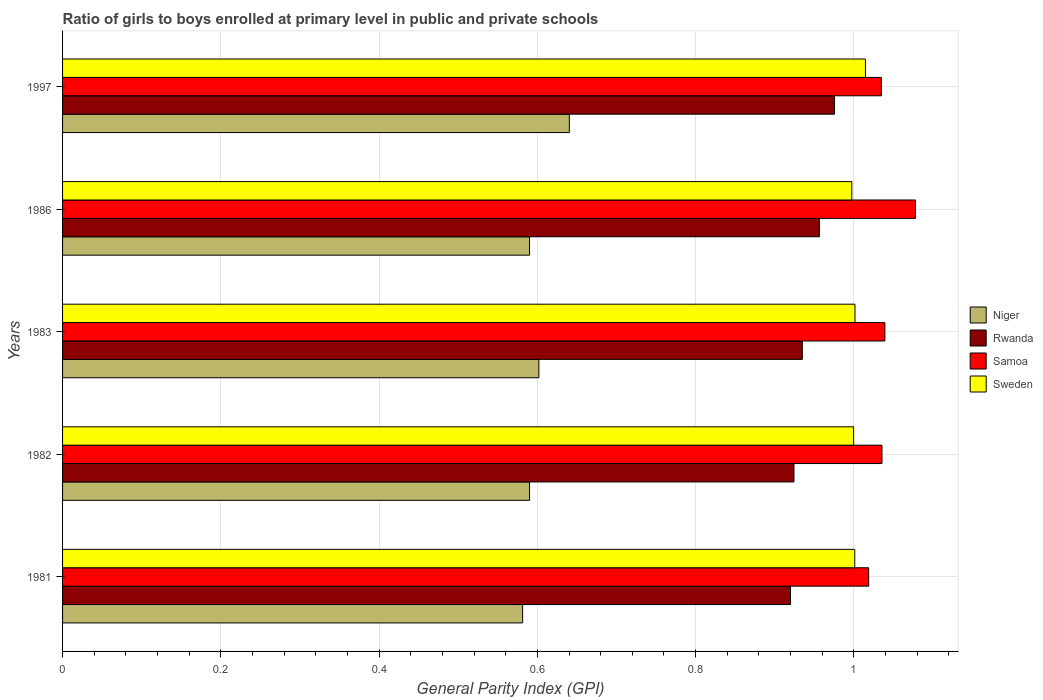Are the number of bars per tick equal to the number of legend labels?
Make the answer very short. Yes. Are the number of bars on each tick of the Y-axis equal?
Your response must be concise. Yes. How many bars are there on the 4th tick from the top?
Your answer should be very brief. 4. How many bars are there on the 5th tick from the bottom?
Ensure brevity in your answer.  4. In how many cases, is the number of bars for a given year not equal to the number of legend labels?
Offer a very short reply. 0. What is the general parity index in Sweden in 1986?
Keep it short and to the point. 1. Across all years, what is the maximum general parity index in Rwanda?
Provide a short and direct response. 0.98. Across all years, what is the minimum general parity index in Samoa?
Provide a short and direct response. 1.02. What is the total general parity index in Sweden in the graph?
Offer a very short reply. 5.01. What is the difference between the general parity index in Samoa in 1981 and that in 1982?
Your answer should be very brief. -0.02. What is the difference between the general parity index in Rwanda in 1997 and the general parity index in Niger in 1982?
Provide a succinct answer. 0.39. What is the average general parity index in Sweden per year?
Offer a terse response. 1. In the year 1986, what is the difference between the general parity index in Samoa and general parity index in Rwanda?
Keep it short and to the point. 0.12. In how many years, is the general parity index in Rwanda greater than 0.2 ?
Offer a terse response. 5. What is the ratio of the general parity index in Niger in 1983 to that in 1997?
Your response must be concise. 0.94. Is the general parity index in Niger in 1982 less than that in 1997?
Keep it short and to the point. Yes. Is the difference between the general parity index in Samoa in 1981 and 1997 greater than the difference between the general parity index in Rwanda in 1981 and 1997?
Offer a terse response. Yes. What is the difference between the highest and the second highest general parity index in Sweden?
Keep it short and to the point. 0.01. What is the difference between the highest and the lowest general parity index in Samoa?
Provide a short and direct response. 0.06. What does the 2nd bar from the top in 1986 represents?
Ensure brevity in your answer.  Samoa. What does the 4th bar from the bottom in 1982 represents?
Your answer should be compact. Sweden. How many bars are there?
Offer a very short reply. 20. Are the values on the major ticks of X-axis written in scientific E-notation?
Make the answer very short. No. Does the graph contain grids?
Provide a short and direct response. Yes. Where does the legend appear in the graph?
Your answer should be compact. Center right. How many legend labels are there?
Your response must be concise. 4. What is the title of the graph?
Ensure brevity in your answer.  Ratio of girls to boys enrolled at primary level in public and private schools. Does "Turkmenistan" appear as one of the legend labels in the graph?
Give a very brief answer. No. What is the label or title of the X-axis?
Keep it short and to the point. General Parity Index (GPI). What is the label or title of the Y-axis?
Offer a very short reply. Years. What is the General Parity Index (GPI) in Niger in 1981?
Keep it short and to the point. 0.58. What is the General Parity Index (GPI) of Rwanda in 1981?
Your response must be concise. 0.92. What is the General Parity Index (GPI) of Samoa in 1981?
Your response must be concise. 1.02. What is the General Parity Index (GPI) in Sweden in 1981?
Provide a succinct answer. 1. What is the General Parity Index (GPI) in Niger in 1982?
Offer a terse response. 0.59. What is the General Parity Index (GPI) in Rwanda in 1982?
Ensure brevity in your answer.  0.92. What is the General Parity Index (GPI) of Samoa in 1982?
Offer a very short reply. 1.04. What is the General Parity Index (GPI) in Sweden in 1982?
Offer a very short reply. 1. What is the General Parity Index (GPI) in Niger in 1983?
Your answer should be compact. 0.6. What is the General Parity Index (GPI) in Rwanda in 1983?
Ensure brevity in your answer.  0.93. What is the General Parity Index (GPI) of Samoa in 1983?
Ensure brevity in your answer.  1.04. What is the General Parity Index (GPI) of Sweden in 1983?
Keep it short and to the point. 1. What is the General Parity Index (GPI) in Niger in 1986?
Ensure brevity in your answer.  0.59. What is the General Parity Index (GPI) of Rwanda in 1986?
Your answer should be compact. 0.96. What is the General Parity Index (GPI) of Samoa in 1986?
Make the answer very short. 1.08. What is the General Parity Index (GPI) in Sweden in 1986?
Offer a terse response. 1. What is the General Parity Index (GPI) of Niger in 1997?
Ensure brevity in your answer.  0.64. What is the General Parity Index (GPI) of Rwanda in 1997?
Make the answer very short. 0.98. What is the General Parity Index (GPI) of Samoa in 1997?
Provide a succinct answer. 1.03. What is the General Parity Index (GPI) in Sweden in 1997?
Keep it short and to the point. 1.01. Across all years, what is the maximum General Parity Index (GPI) of Niger?
Your answer should be compact. 0.64. Across all years, what is the maximum General Parity Index (GPI) in Rwanda?
Your response must be concise. 0.98. Across all years, what is the maximum General Parity Index (GPI) in Samoa?
Provide a short and direct response. 1.08. Across all years, what is the maximum General Parity Index (GPI) in Sweden?
Ensure brevity in your answer.  1.01. Across all years, what is the minimum General Parity Index (GPI) in Niger?
Offer a very short reply. 0.58. Across all years, what is the minimum General Parity Index (GPI) of Rwanda?
Provide a short and direct response. 0.92. Across all years, what is the minimum General Parity Index (GPI) in Samoa?
Offer a terse response. 1.02. Across all years, what is the minimum General Parity Index (GPI) in Sweden?
Offer a very short reply. 1. What is the total General Parity Index (GPI) of Niger in the graph?
Give a very brief answer. 3. What is the total General Parity Index (GPI) in Rwanda in the graph?
Offer a very short reply. 4.71. What is the total General Parity Index (GPI) of Samoa in the graph?
Offer a very short reply. 5.21. What is the total General Parity Index (GPI) in Sweden in the graph?
Make the answer very short. 5.01. What is the difference between the General Parity Index (GPI) of Niger in 1981 and that in 1982?
Provide a short and direct response. -0.01. What is the difference between the General Parity Index (GPI) in Rwanda in 1981 and that in 1982?
Offer a terse response. -0. What is the difference between the General Parity Index (GPI) of Samoa in 1981 and that in 1982?
Your answer should be very brief. -0.02. What is the difference between the General Parity Index (GPI) in Sweden in 1981 and that in 1982?
Offer a very short reply. 0. What is the difference between the General Parity Index (GPI) in Niger in 1981 and that in 1983?
Give a very brief answer. -0.02. What is the difference between the General Parity Index (GPI) in Rwanda in 1981 and that in 1983?
Make the answer very short. -0.01. What is the difference between the General Parity Index (GPI) in Samoa in 1981 and that in 1983?
Make the answer very short. -0.02. What is the difference between the General Parity Index (GPI) of Sweden in 1981 and that in 1983?
Your answer should be very brief. -0. What is the difference between the General Parity Index (GPI) of Niger in 1981 and that in 1986?
Your response must be concise. -0.01. What is the difference between the General Parity Index (GPI) of Rwanda in 1981 and that in 1986?
Your response must be concise. -0.04. What is the difference between the General Parity Index (GPI) in Samoa in 1981 and that in 1986?
Give a very brief answer. -0.06. What is the difference between the General Parity Index (GPI) of Sweden in 1981 and that in 1986?
Your response must be concise. 0. What is the difference between the General Parity Index (GPI) of Niger in 1981 and that in 1997?
Give a very brief answer. -0.06. What is the difference between the General Parity Index (GPI) in Rwanda in 1981 and that in 1997?
Provide a succinct answer. -0.06. What is the difference between the General Parity Index (GPI) of Samoa in 1981 and that in 1997?
Your answer should be compact. -0.02. What is the difference between the General Parity Index (GPI) of Sweden in 1981 and that in 1997?
Provide a succinct answer. -0.01. What is the difference between the General Parity Index (GPI) of Niger in 1982 and that in 1983?
Your answer should be very brief. -0.01. What is the difference between the General Parity Index (GPI) in Rwanda in 1982 and that in 1983?
Give a very brief answer. -0.01. What is the difference between the General Parity Index (GPI) in Samoa in 1982 and that in 1983?
Your response must be concise. -0. What is the difference between the General Parity Index (GPI) of Sweden in 1982 and that in 1983?
Give a very brief answer. -0. What is the difference between the General Parity Index (GPI) in Rwanda in 1982 and that in 1986?
Offer a terse response. -0.03. What is the difference between the General Parity Index (GPI) in Samoa in 1982 and that in 1986?
Offer a terse response. -0.04. What is the difference between the General Parity Index (GPI) of Sweden in 1982 and that in 1986?
Your answer should be very brief. 0. What is the difference between the General Parity Index (GPI) in Niger in 1982 and that in 1997?
Offer a terse response. -0.05. What is the difference between the General Parity Index (GPI) in Rwanda in 1982 and that in 1997?
Offer a very short reply. -0.05. What is the difference between the General Parity Index (GPI) of Samoa in 1982 and that in 1997?
Offer a terse response. 0. What is the difference between the General Parity Index (GPI) of Sweden in 1982 and that in 1997?
Make the answer very short. -0.01. What is the difference between the General Parity Index (GPI) of Niger in 1983 and that in 1986?
Make the answer very short. 0.01. What is the difference between the General Parity Index (GPI) in Rwanda in 1983 and that in 1986?
Provide a succinct answer. -0.02. What is the difference between the General Parity Index (GPI) in Samoa in 1983 and that in 1986?
Give a very brief answer. -0.04. What is the difference between the General Parity Index (GPI) in Sweden in 1983 and that in 1986?
Provide a succinct answer. 0. What is the difference between the General Parity Index (GPI) of Niger in 1983 and that in 1997?
Ensure brevity in your answer.  -0.04. What is the difference between the General Parity Index (GPI) in Rwanda in 1983 and that in 1997?
Provide a succinct answer. -0.04. What is the difference between the General Parity Index (GPI) in Samoa in 1983 and that in 1997?
Provide a succinct answer. 0. What is the difference between the General Parity Index (GPI) of Sweden in 1983 and that in 1997?
Offer a very short reply. -0.01. What is the difference between the General Parity Index (GPI) in Niger in 1986 and that in 1997?
Give a very brief answer. -0.05. What is the difference between the General Parity Index (GPI) of Rwanda in 1986 and that in 1997?
Provide a short and direct response. -0.02. What is the difference between the General Parity Index (GPI) in Samoa in 1986 and that in 1997?
Offer a terse response. 0.04. What is the difference between the General Parity Index (GPI) in Sweden in 1986 and that in 1997?
Your answer should be very brief. -0.02. What is the difference between the General Parity Index (GPI) in Niger in 1981 and the General Parity Index (GPI) in Rwanda in 1982?
Offer a very short reply. -0.34. What is the difference between the General Parity Index (GPI) in Niger in 1981 and the General Parity Index (GPI) in Samoa in 1982?
Keep it short and to the point. -0.45. What is the difference between the General Parity Index (GPI) in Niger in 1981 and the General Parity Index (GPI) in Sweden in 1982?
Make the answer very short. -0.42. What is the difference between the General Parity Index (GPI) of Rwanda in 1981 and the General Parity Index (GPI) of Samoa in 1982?
Provide a succinct answer. -0.12. What is the difference between the General Parity Index (GPI) of Rwanda in 1981 and the General Parity Index (GPI) of Sweden in 1982?
Ensure brevity in your answer.  -0.08. What is the difference between the General Parity Index (GPI) of Samoa in 1981 and the General Parity Index (GPI) of Sweden in 1982?
Your response must be concise. 0.02. What is the difference between the General Parity Index (GPI) of Niger in 1981 and the General Parity Index (GPI) of Rwanda in 1983?
Your answer should be compact. -0.35. What is the difference between the General Parity Index (GPI) of Niger in 1981 and the General Parity Index (GPI) of Samoa in 1983?
Ensure brevity in your answer.  -0.46. What is the difference between the General Parity Index (GPI) of Niger in 1981 and the General Parity Index (GPI) of Sweden in 1983?
Your answer should be compact. -0.42. What is the difference between the General Parity Index (GPI) of Rwanda in 1981 and the General Parity Index (GPI) of Samoa in 1983?
Your response must be concise. -0.12. What is the difference between the General Parity Index (GPI) of Rwanda in 1981 and the General Parity Index (GPI) of Sweden in 1983?
Provide a succinct answer. -0.08. What is the difference between the General Parity Index (GPI) in Samoa in 1981 and the General Parity Index (GPI) in Sweden in 1983?
Keep it short and to the point. 0.02. What is the difference between the General Parity Index (GPI) of Niger in 1981 and the General Parity Index (GPI) of Rwanda in 1986?
Provide a succinct answer. -0.38. What is the difference between the General Parity Index (GPI) of Niger in 1981 and the General Parity Index (GPI) of Samoa in 1986?
Give a very brief answer. -0.5. What is the difference between the General Parity Index (GPI) in Niger in 1981 and the General Parity Index (GPI) in Sweden in 1986?
Your answer should be very brief. -0.42. What is the difference between the General Parity Index (GPI) in Rwanda in 1981 and the General Parity Index (GPI) in Samoa in 1986?
Your answer should be very brief. -0.16. What is the difference between the General Parity Index (GPI) in Rwanda in 1981 and the General Parity Index (GPI) in Sweden in 1986?
Give a very brief answer. -0.08. What is the difference between the General Parity Index (GPI) in Samoa in 1981 and the General Parity Index (GPI) in Sweden in 1986?
Ensure brevity in your answer.  0.02. What is the difference between the General Parity Index (GPI) of Niger in 1981 and the General Parity Index (GPI) of Rwanda in 1997?
Your answer should be compact. -0.39. What is the difference between the General Parity Index (GPI) in Niger in 1981 and the General Parity Index (GPI) in Samoa in 1997?
Provide a short and direct response. -0.45. What is the difference between the General Parity Index (GPI) in Niger in 1981 and the General Parity Index (GPI) in Sweden in 1997?
Offer a very short reply. -0.43. What is the difference between the General Parity Index (GPI) of Rwanda in 1981 and the General Parity Index (GPI) of Samoa in 1997?
Offer a very short reply. -0.11. What is the difference between the General Parity Index (GPI) of Rwanda in 1981 and the General Parity Index (GPI) of Sweden in 1997?
Give a very brief answer. -0.09. What is the difference between the General Parity Index (GPI) in Samoa in 1981 and the General Parity Index (GPI) in Sweden in 1997?
Make the answer very short. 0. What is the difference between the General Parity Index (GPI) in Niger in 1982 and the General Parity Index (GPI) in Rwanda in 1983?
Your response must be concise. -0.34. What is the difference between the General Parity Index (GPI) of Niger in 1982 and the General Parity Index (GPI) of Samoa in 1983?
Offer a very short reply. -0.45. What is the difference between the General Parity Index (GPI) in Niger in 1982 and the General Parity Index (GPI) in Sweden in 1983?
Provide a short and direct response. -0.41. What is the difference between the General Parity Index (GPI) in Rwanda in 1982 and the General Parity Index (GPI) in Samoa in 1983?
Give a very brief answer. -0.11. What is the difference between the General Parity Index (GPI) in Rwanda in 1982 and the General Parity Index (GPI) in Sweden in 1983?
Your answer should be very brief. -0.08. What is the difference between the General Parity Index (GPI) of Samoa in 1982 and the General Parity Index (GPI) of Sweden in 1983?
Give a very brief answer. 0.03. What is the difference between the General Parity Index (GPI) of Niger in 1982 and the General Parity Index (GPI) of Rwanda in 1986?
Make the answer very short. -0.37. What is the difference between the General Parity Index (GPI) of Niger in 1982 and the General Parity Index (GPI) of Samoa in 1986?
Offer a terse response. -0.49. What is the difference between the General Parity Index (GPI) in Niger in 1982 and the General Parity Index (GPI) in Sweden in 1986?
Give a very brief answer. -0.41. What is the difference between the General Parity Index (GPI) in Rwanda in 1982 and the General Parity Index (GPI) in Samoa in 1986?
Provide a succinct answer. -0.15. What is the difference between the General Parity Index (GPI) of Rwanda in 1982 and the General Parity Index (GPI) of Sweden in 1986?
Your answer should be compact. -0.07. What is the difference between the General Parity Index (GPI) of Samoa in 1982 and the General Parity Index (GPI) of Sweden in 1986?
Give a very brief answer. 0.04. What is the difference between the General Parity Index (GPI) in Niger in 1982 and the General Parity Index (GPI) in Rwanda in 1997?
Give a very brief answer. -0.39. What is the difference between the General Parity Index (GPI) of Niger in 1982 and the General Parity Index (GPI) of Samoa in 1997?
Your answer should be compact. -0.44. What is the difference between the General Parity Index (GPI) in Niger in 1982 and the General Parity Index (GPI) in Sweden in 1997?
Offer a very short reply. -0.42. What is the difference between the General Parity Index (GPI) in Rwanda in 1982 and the General Parity Index (GPI) in Samoa in 1997?
Provide a short and direct response. -0.11. What is the difference between the General Parity Index (GPI) of Rwanda in 1982 and the General Parity Index (GPI) of Sweden in 1997?
Provide a short and direct response. -0.09. What is the difference between the General Parity Index (GPI) of Samoa in 1982 and the General Parity Index (GPI) of Sweden in 1997?
Offer a very short reply. 0.02. What is the difference between the General Parity Index (GPI) in Niger in 1983 and the General Parity Index (GPI) in Rwanda in 1986?
Your response must be concise. -0.35. What is the difference between the General Parity Index (GPI) of Niger in 1983 and the General Parity Index (GPI) of Samoa in 1986?
Give a very brief answer. -0.48. What is the difference between the General Parity Index (GPI) of Niger in 1983 and the General Parity Index (GPI) of Sweden in 1986?
Provide a succinct answer. -0.4. What is the difference between the General Parity Index (GPI) in Rwanda in 1983 and the General Parity Index (GPI) in Samoa in 1986?
Your answer should be very brief. -0.14. What is the difference between the General Parity Index (GPI) of Rwanda in 1983 and the General Parity Index (GPI) of Sweden in 1986?
Give a very brief answer. -0.06. What is the difference between the General Parity Index (GPI) in Samoa in 1983 and the General Parity Index (GPI) in Sweden in 1986?
Ensure brevity in your answer.  0.04. What is the difference between the General Parity Index (GPI) in Niger in 1983 and the General Parity Index (GPI) in Rwanda in 1997?
Offer a very short reply. -0.37. What is the difference between the General Parity Index (GPI) of Niger in 1983 and the General Parity Index (GPI) of Samoa in 1997?
Make the answer very short. -0.43. What is the difference between the General Parity Index (GPI) in Niger in 1983 and the General Parity Index (GPI) in Sweden in 1997?
Provide a short and direct response. -0.41. What is the difference between the General Parity Index (GPI) in Rwanda in 1983 and the General Parity Index (GPI) in Samoa in 1997?
Your answer should be compact. -0.1. What is the difference between the General Parity Index (GPI) in Rwanda in 1983 and the General Parity Index (GPI) in Sweden in 1997?
Make the answer very short. -0.08. What is the difference between the General Parity Index (GPI) in Samoa in 1983 and the General Parity Index (GPI) in Sweden in 1997?
Keep it short and to the point. 0.02. What is the difference between the General Parity Index (GPI) in Niger in 1986 and the General Parity Index (GPI) in Rwanda in 1997?
Provide a succinct answer. -0.39. What is the difference between the General Parity Index (GPI) in Niger in 1986 and the General Parity Index (GPI) in Samoa in 1997?
Offer a terse response. -0.44. What is the difference between the General Parity Index (GPI) in Niger in 1986 and the General Parity Index (GPI) in Sweden in 1997?
Offer a very short reply. -0.42. What is the difference between the General Parity Index (GPI) in Rwanda in 1986 and the General Parity Index (GPI) in Samoa in 1997?
Ensure brevity in your answer.  -0.08. What is the difference between the General Parity Index (GPI) in Rwanda in 1986 and the General Parity Index (GPI) in Sweden in 1997?
Keep it short and to the point. -0.06. What is the difference between the General Parity Index (GPI) in Samoa in 1986 and the General Parity Index (GPI) in Sweden in 1997?
Make the answer very short. 0.06. What is the average General Parity Index (GPI) in Niger per year?
Provide a succinct answer. 0.6. What is the average General Parity Index (GPI) in Rwanda per year?
Your response must be concise. 0.94. What is the average General Parity Index (GPI) in Samoa per year?
Offer a very short reply. 1.04. What is the average General Parity Index (GPI) of Sweden per year?
Provide a succinct answer. 1. In the year 1981, what is the difference between the General Parity Index (GPI) in Niger and General Parity Index (GPI) in Rwanda?
Your response must be concise. -0.34. In the year 1981, what is the difference between the General Parity Index (GPI) in Niger and General Parity Index (GPI) in Samoa?
Ensure brevity in your answer.  -0.44. In the year 1981, what is the difference between the General Parity Index (GPI) of Niger and General Parity Index (GPI) of Sweden?
Offer a terse response. -0.42. In the year 1981, what is the difference between the General Parity Index (GPI) in Rwanda and General Parity Index (GPI) in Samoa?
Ensure brevity in your answer.  -0.1. In the year 1981, what is the difference between the General Parity Index (GPI) of Rwanda and General Parity Index (GPI) of Sweden?
Ensure brevity in your answer.  -0.08. In the year 1981, what is the difference between the General Parity Index (GPI) of Samoa and General Parity Index (GPI) of Sweden?
Your answer should be compact. 0.02. In the year 1982, what is the difference between the General Parity Index (GPI) in Niger and General Parity Index (GPI) in Rwanda?
Make the answer very short. -0.33. In the year 1982, what is the difference between the General Parity Index (GPI) in Niger and General Parity Index (GPI) in Samoa?
Ensure brevity in your answer.  -0.45. In the year 1982, what is the difference between the General Parity Index (GPI) of Niger and General Parity Index (GPI) of Sweden?
Give a very brief answer. -0.41. In the year 1982, what is the difference between the General Parity Index (GPI) of Rwanda and General Parity Index (GPI) of Samoa?
Your answer should be compact. -0.11. In the year 1982, what is the difference between the General Parity Index (GPI) in Rwanda and General Parity Index (GPI) in Sweden?
Provide a short and direct response. -0.08. In the year 1982, what is the difference between the General Parity Index (GPI) in Samoa and General Parity Index (GPI) in Sweden?
Give a very brief answer. 0.04. In the year 1983, what is the difference between the General Parity Index (GPI) of Niger and General Parity Index (GPI) of Rwanda?
Your answer should be compact. -0.33. In the year 1983, what is the difference between the General Parity Index (GPI) of Niger and General Parity Index (GPI) of Samoa?
Provide a succinct answer. -0.44. In the year 1983, what is the difference between the General Parity Index (GPI) in Niger and General Parity Index (GPI) in Sweden?
Provide a succinct answer. -0.4. In the year 1983, what is the difference between the General Parity Index (GPI) in Rwanda and General Parity Index (GPI) in Samoa?
Your answer should be compact. -0.1. In the year 1983, what is the difference between the General Parity Index (GPI) in Rwanda and General Parity Index (GPI) in Sweden?
Provide a succinct answer. -0.07. In the year 1983, what is the difference between the General Parity Index (GPI) of Samoa and General Parity Index (GPI) of Sweden?
Provide a short and direct response. 0.04. In the year 1986, what is the difference between the General Parity Index (GPI) of Niger and General Parity Index (GPI) of Rwanda?
Your response must be concise. -0.37. In the year 1986, what is the difference between the General Parity Index (GPI) of Niger and General Parity Index (GPI) of Samoa?
Provide a succinct answer. -0.49. In the year 1986, what is the difference between the General Parity Index (GPI) in Niger and General Parity Index (GPI) in Sweden?
Make the answer very short. -0.41. In the year 1986, what is the difference between the General Parity Index (GPI) in Rwanda and General Parity Index (GPI) in Samoa?
Your answer should be very brief. -0.12. In the year 1986, what is the difference between the General Parity Index (GPI) of Rwanda and General Parity Index (GPI) of Sweden?
Ensure brevity in your answer.  -0.04. In the year 1986, what is the difference between the General Parity Index (GPI) of Samoa and General Parity Index (GPI) of Sweden?
Keep it short and to the point. 0.08. In the year 1997, what is the difference between the General Parity Index (GPI) in Niger and General Parity Index (GPI) in Rwanda?
Offer a terse response. -0.34. In the year 1997, what is the difference between the General Parity Index (GPI) of Niger and General Parity Index (GPI) of Samoa?
Your answer should be very brief. -0.39. In the year 1997, what is the difference between the General Parity Index (GPI) of Niger and General Parity Index (GPI) of Sweden?
Offer a terse response. -0.37. In the year 1997, what is the difference between the General Parity Index (GPI) in Rwanda and General Parity Index (GPI) in Samoa?
Your answer should be compact. -0.06. In the year 1997, what is the difference between the General Parity Index (GPI) of Rwanda and General Parity Index (GPI) of Sweden?
Ensure brevity in your answer.  -0.04. In the year 1997, what is the difference between the General Parity Index (GPI) of Samoa and General Parity Index (GPI) of Sweden?
Provide a short and direct response. 0.02. What is the ratio of the General Parity Index (GPI) in Niger in 1981 to that in 1982?
Offer a terse response. 0.99. What is the ratio of the General Parity Index (GPI) in Rwanda in 1981 to that in 1982?
Make the answer very short. 1. What is the ratio of the General Parity Index (GPI) of Samoa in 1981 to that in 1982?
Make the answer very short. 0.98. What is the ratio of the General Parity Index (GPI) in Niger in 1981 to that in 1983?
Provide a short and direct response. 0.97. What is the ratio of the General Parity Index (GPI) of Samoa in 1981 to that in 1983?
Your response must be concise. 0.98. What is the ratio of the General Parity Index (GPI) of Sweden in 1981 to that in 1983?
Keep it short and to the point. 1. What is the ratio of the General Parity Index (GPI) in Rwanda in 1981 to that in 1986?
Provide a succinct answer. 0.96. What is the ratio of the General Parity Index (GPI) in Samoa in 1981 to that in 1986?
Offer a very short reply. 0.95. What is the ratio of the General Parity Index (GPI) in Sweden in 1981 to that in 1986?
Offer a very short reply. 1. What is the ratio of the General Parity Index (GPI) of Niger in 1981 to that in 1997?
Give a very brief answer. 0.91. What is the ratio of the General Parity Index (GPI) in Rwanda in 1981 to that in 1997?
Your response must be concise. 0.94. What is the ratio of the General Parity Index (GPI) of Samoa in 1981 to that in 1997?
Offer a very short reply. 0.98. What is the ratio of the General Parity Index (GPI) in Sweden in 1981 to that in 1997?
Give a very brief answer. 0.99. What is the ratio of the General Parity Index (GPI) in Niger in 1982 to that in 1983?
Ensure brevity in your answer.  0.98. What is the ratio of the General Parity Index (GPI) in Rwanda in 1982 to that in 1983?
Your response must be concise. 0.99. What is the ratio of the General Parity Index (GPI) of Samoa in 1982 to that in 1983?
Give a very brief answer. 1. What is the ratio of the General Parity Index (GPI) of Sweden in 1982 to that in 1983?
Keep it short and to the point. 1. What is the ratio of the General Parity Index (GPI) in Niger in 1982 to that in 1986?
Your response must be concise. 1. What is the ratio of the General Parity Index (GPI) of Rwanda in 1982 to that in 1986?
Make the answer very short. 0.97. What is the ratio of the General Parity Index (GPI) in Samoa in 1982 to that in 1986?
Provide a short and direct response. 0.96. What is the ratio of the General Parity Index (GPI) of Sweden in 1982 to that in 1986?
Make the answer very short. 1. What is the ratio of the General Parity Index (GPI) in Niger in 1982 to that in 1997?
Your answer should be very brief. 0.92. What is the ratio of the General Parity Index (GPI) of Rwanda in 1982 to that in 1997?
Offer a very short reply. 0.95. What is the ratio of the General Parity Index (GPI) of Samoa in 1982 to that in 1997?
Provide a short and direct response. 1. What is the ratio of the General Parity Index (GPI) in Niger in 1983 to that in 1986?
Your response must be concise. 1.02. What is the ratio of the General Parity Index (GPI) in Rwanda in 1983 to that in 1986?
Ensure brevity in your answer.  0.98. What is the ratio of the General Parity Index (GPI) in Samoa in 1983 to that in 1986?
Your answer should be compact. 0.96. What is the ratio of the General Parity Index (GPI) of Niger in 1983 to that in 1997?
Your answer should be very brief. 0.94. What is the ratio of the General Parity Index (GPI) of Rwanda in 1983 to that in 1997?
Provide a short and direct response. 0.96. What is the ratio of the General Parity Index (GPI) of Niger in 1986 to that in 1997?
Provide a short and direct response. 0.92. What is the ratio of the General Parity Index (GPI) in Rwanda in 1986 to that in 1997?
Ensure brevity in your answer.  0.98. What is the ratio of the General Parity Index (GPI) of Samoa in 1986 to that in 1997?
Your answer should be compact. 1.04. What is the difference between the highest and the second highest General Parity Index (GPI) of Niger?
Your answer should be compact. 0.04. What is the difference between the highest and the second highest General Parity Index (GPI) in Rwanda?
Your answer should be compact. 0.02. What is the difference between the highest and the second highest General Parity Index (GPI) of Samoa?
Your answer should be compact. 0.04. What is the difference between the highest and the second highest General Parity Index (GPI) of Sweden?
Ensure brevity in your answer.  0.01. What is the difference between the highest and the lowest General Parity Index (GPI) in Niger?
Give a very brief answer. 0.06. What is the difference between the highest and the lowest General Parity Index (GPI) in Rwanda?
Give a very brief answer. 0.06. What is the difference between the highest and the lowest General Parity Index (GPI) of Samoa?
Your response must be concise. 0.06. What is the difference between the highest and the lowest General Parity Index (GPI) in Sweden?
Your answer should be compact. 0.02. 